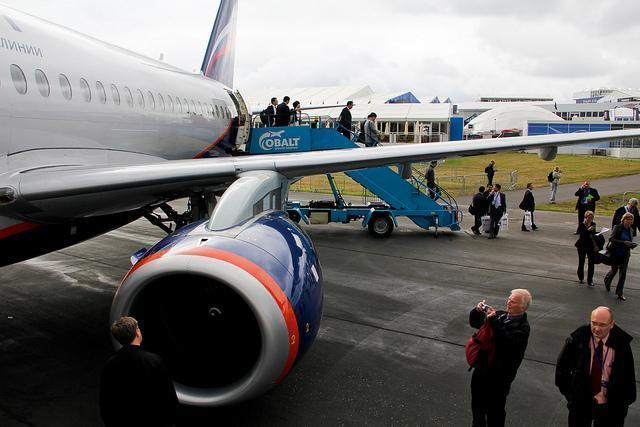What is the man with the red backpack on the right doing?
Make your selection and explain in format: 'Answer: answer
Rationale: rationale.'
Options: Drawing, exercising, taking photo, playing instrument. Answer: taking photo.
Rationale: The man is holding a camera visibly and is looking through the lens based on his body position and eye line. someone looking through the lens of a camera is likely to be taking pictures. 